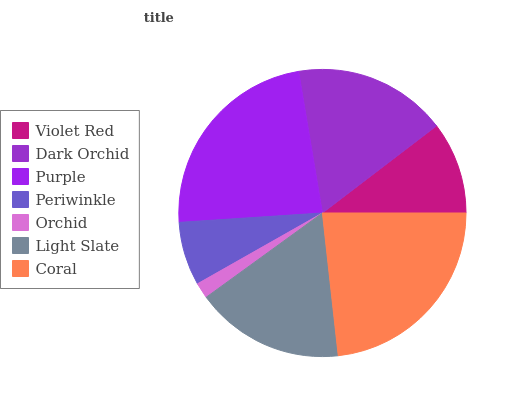Is Orchid the minimum?
Answer yes or no. Yes. Is Purple the maximum?
Answer yes or no. Yes. Is Dark Orchid the minimum?
Answer yes or no. No. Is Dark Orchid the maximum?
Answer yes or no. No. Is Dark Orchid greater than Violet Red?
Answer yes or no. Yes. Is Violet Red less than Dark Orchid?
Answer yes or no. Yes. Is Violet Red greater than Dark Orchid?
Answer yes or no. No. Is Dark Orchid less than Violet Red?
Answer yes or no. No. Is Light Slate the high median?
Answer yes or no. Yes. Is Light Slate the low median?
Answer yes or no. Yes. Is Violet Red the high median?
Answer yes or no. No. Is Dark Orchid the low median?
Answer yes or no. No. 